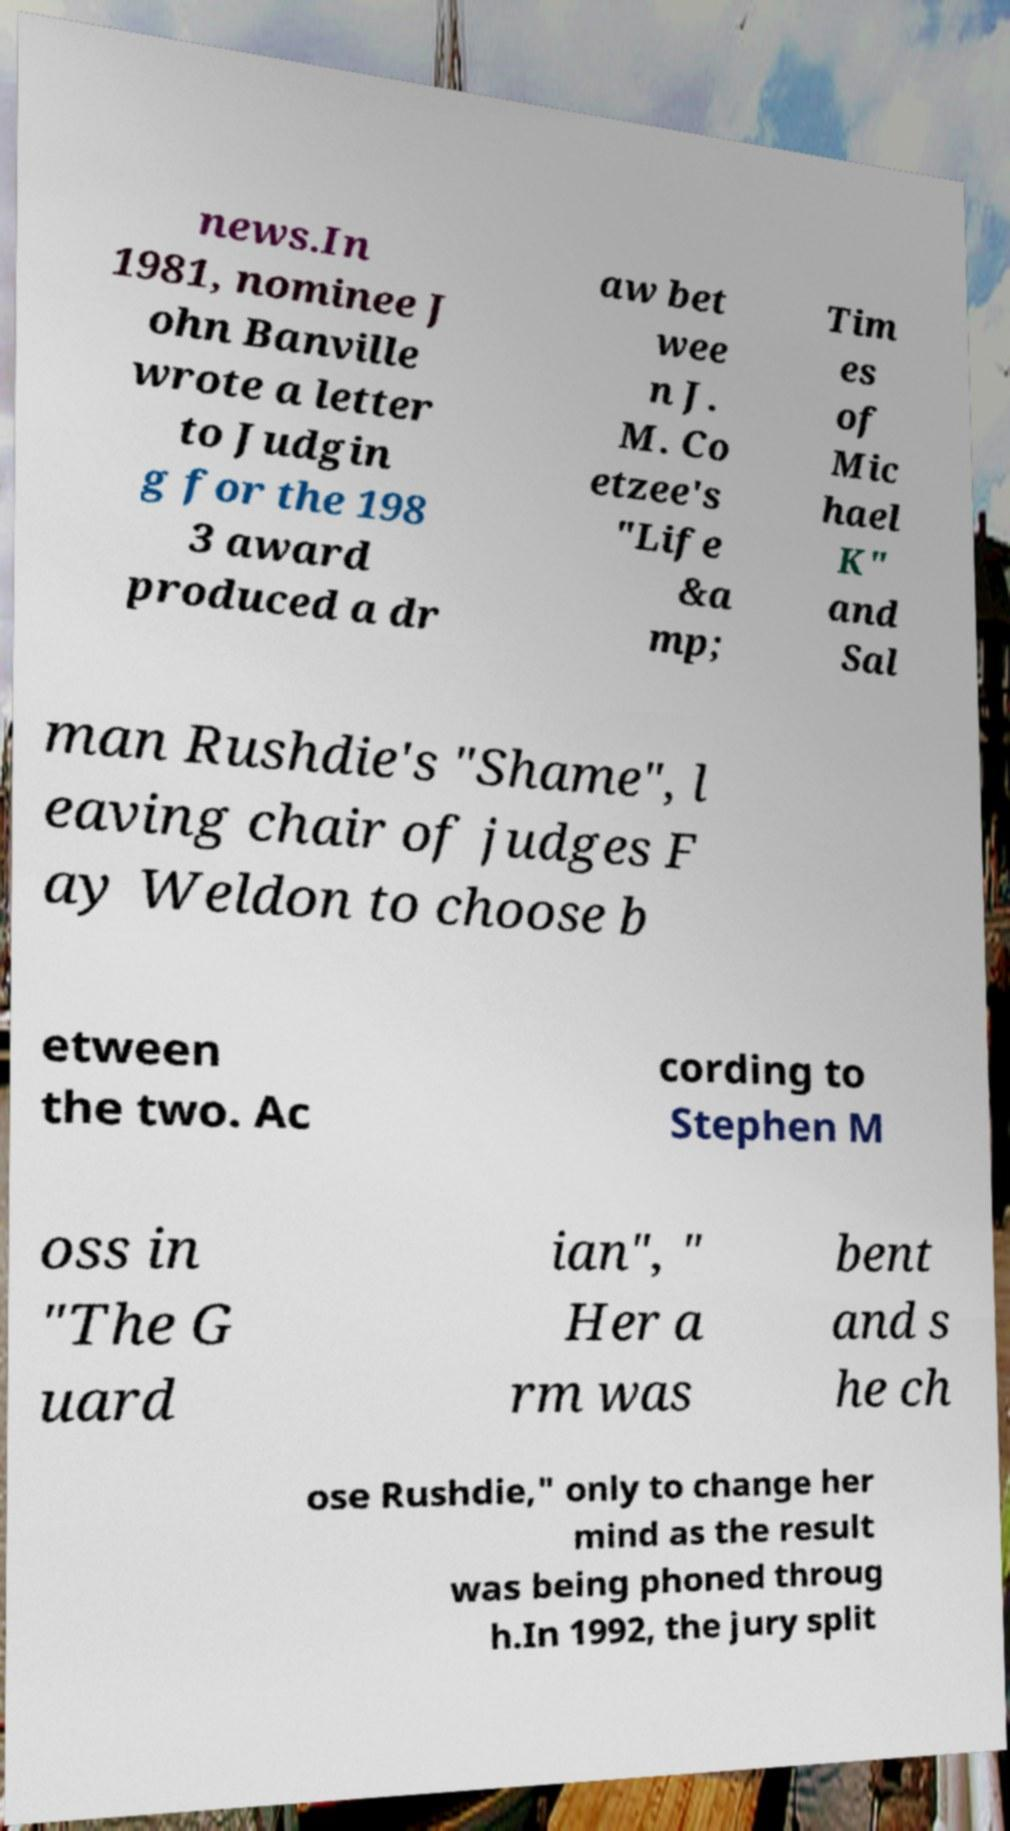Could you assist in decoding the text presented in this image and type it out clearly? news.In 1981, nominee J ohn Banville wrote a letter to Judgin g for the 198 3 award produced a dr aw bet wee n J. M. Co etzee's "Life &a mp; Tim es of Mic hael K" and Sal man Rushdie's "Shame", l eaving chair of judges F ay Weldon to choose b etween the two. Ac cording to Stephen M oss in "The G uard ian", " Her a rm was bent and s he ch ose Rushdie," only to change her mind as the result was being phoned throug h.In 1992, the jury split 